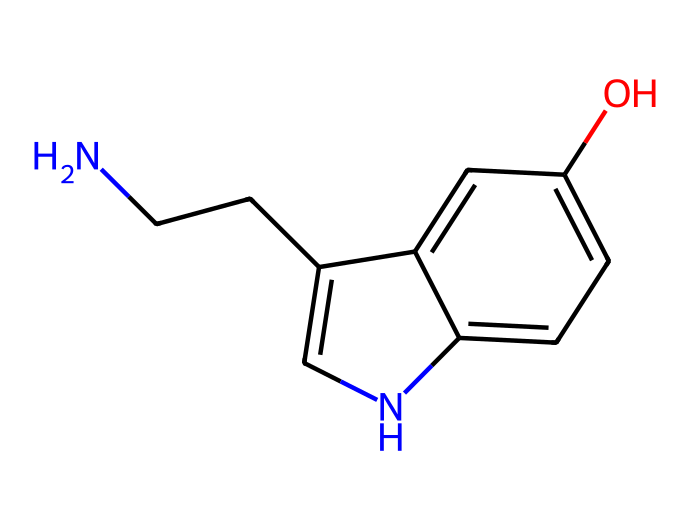What is the molecular formula of serotonin? To find the molecular formula, we count the number of each type of atom in the SMILES representation. The SMILES shows: 2 Nitrogen (N), 10 Carbon (C), 12 Hydrogen (H), and 1 Oxygen (O). Therefore, the molecular formula is C10H12N2O.
Answer: C10H12N2O How many aromatic rings are present in serotonin? The presence of aromatic rings can be determined by looking for cyclic structures with alternating double bonds in the chemical structure. In serotonin, there are two connected aromatic rings (1 benzene and one indole).
Answer: 2 What functional groups are present in serotonin? By analyzing the structure, we can identify the presence of a hydroxyl (–OH) group and an amine (–NH2) group. The –OH group is indicated by the 'O' within the aromatic ring, and the amine is indicated by the nitrogen attached to the aliphatic chain.
Answer: –OH, –NH2 Is serotonin a polar or non-polar molecule? To determine polarity, we assess the presence of polar functional groups. With the hydroxyl group (–OH) and the amine group (–NH2), which are both polar, serotonin is classified as a polar molecule.
Answer: polar What makes serotonin an aromatic compound? It is considered aromatic because it contains a cyclic structure with conjugated pi electrons, satisfying Huckel's rule (4n + 2), contributing to its stability. The presence of the indole structure also reinforces its aromaticity.
Answer: benzene How many double bonds are present in serotonin's structure? By analyzing the SMILES structure, one can see that there are two double bonds within the indole ring structure, which forms part of the aromatic nature.
Answer: 2 